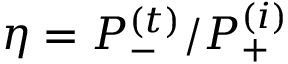Convert formula to latex. <formula><loc_0><loc_0><loc_500><loc_500>\eta = P _ { - } ^ { ( t ) } / P _ { + } ^ { ( i ) }</formula> 